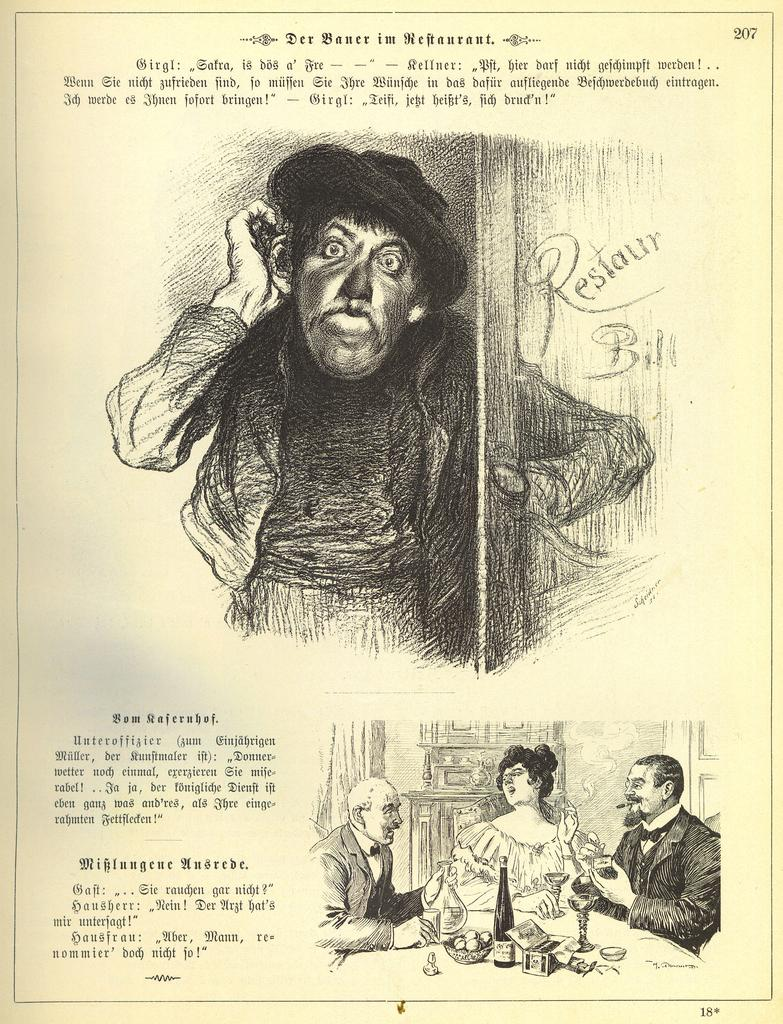What can be found on the page in the image? There is text and a drawing on the page in the image. Can you identify the page number in the image? Yes, the page number is 207 in the top right corner of the image. What type of oil can be seen in the image? There is no oil present in the image. Is there any trouble depicted in the drawing on the page? The image does not provide information about the content of the drawing, so it cannot be determined if there is any trouble depicted. 